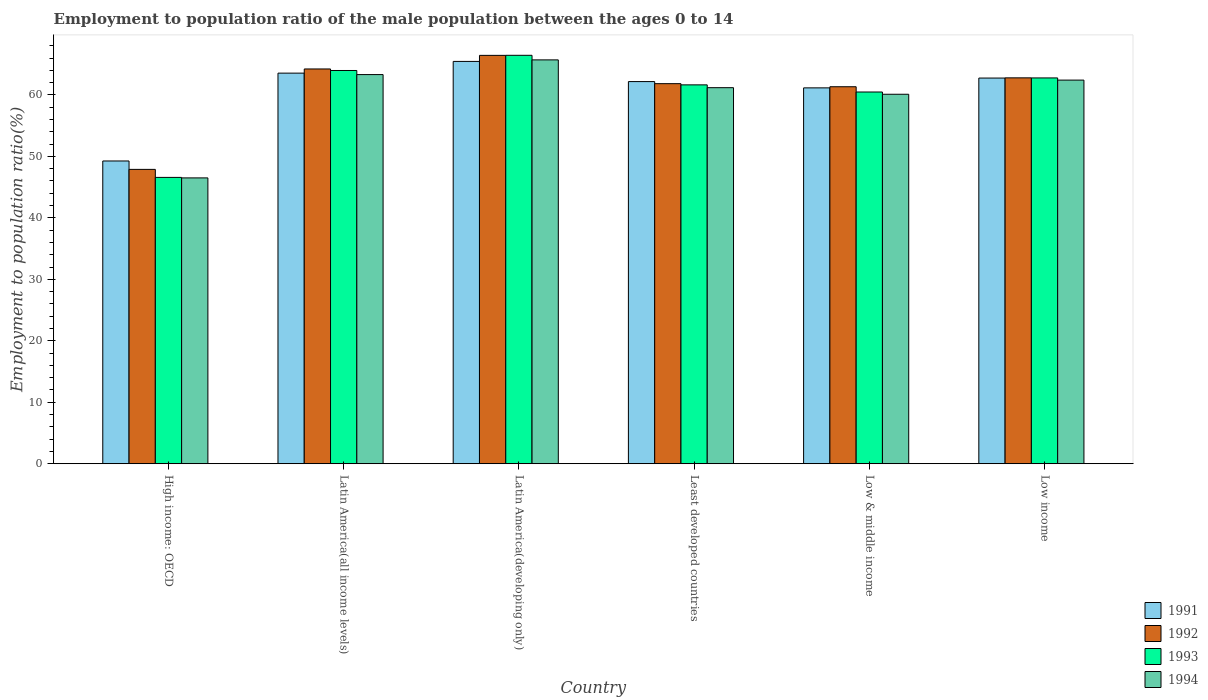Are the number of bars on each tick of the X-axis equal?
Your response must be concise. Yes. How many bars are there on the 2nd tick from the left?
Ensure brevity in your answer.  4. How many bars are there on the 4th tick from the right?
Your answer should be very brief. 4. In how many cases, is the number of bars for a given country not equal to the number of legend labels?
Make the answer very short. 0. What is the employment to population ratio in 1994 in Latin America(all income levels)?
Make the answer very short. 63.31. Across all countries, what is the maximum employment to population ratio in 1994?
Provide a short and direct response. 65.7. Across all countries, what is the minimum employment to population ratio in 1994?
Offer a very short reply. 46.5. In which country was the employment to population ratio in 1991 maximum?
Keep it short and to the point. Latin America(developing only). In which country was the employment to population ratio in 1992 minimum?
Offer a terse response. High income: OECD. What is the total employment to population ratio in 1992 in the graph?
Provide a succinct answer. 364.5. What is the difference between the employment to population ratio in 1992 in Latin America(all income levels) and that in Least developed countries?
Keep it short and to the point. 2.39. What is the difference between the employment to population ratio in 1994 in Latin America(developing only) and the employment to population ratio in 1993 in Low income?
Provide a succinct answer. 2.94. What is the average employment to population ratio in 1994 per country?
Provide a short and direct response. 59.87. What is the difference between the employment to population ratio of/in 1991 and employment to population ratio of/in 1994 in Latin America(all income levels)?
Make the answer very short. 0.24. What is the ratio of the employment to population ratio in 1994 in Latin America(developing only) to that in Low & middle income?
Provide a succinct answer. 1.09. Is the difference between the employment to population ratio in 1991 in Latin America(developing only) and Low income greater than the difference between the employment to population ratio in 1994 in Latin America(developing only) and Low income?
Provide a succinct answer. No. What is the difference between the highest and the second highest employment to population ratio in 1991?
Make the answer very short. 2.71. What is the difference between the highest and the lowest employment to population ratio in 1992?
Offer a very short reply. 18.55. Is it the case that in every country, the sum of the employment to population ratio in 1994 and employment to population ratio in 1993 is greater than the sum of employment to population ratio in 1992 and employment to population ratio in 1991?
Make the answer very short. No. What does the 1st bar from the left in High income: OECD represents?
Keep it short and to the point. 1991. How many bars are there?
Keep it short and to the point. 24. Are all the bars in the graph horizontal?
Give a very brief answer. No. What is the difference between two consecutive major ticks on the Y-axis?
Your answer should be very brief. 10. Are the values on the major ticks of Y-axis written in scientific E-notation?
Offer a terse response. No. Where does the legend appear in the graph?
Your response must be concise. Bottom right. What is the title of the graph?
Your response must be concise. Employment to population ratio of the male population between the ages 0 to 14. What is the label or title of the X-axis?
Your answer should be compact. Country. What is the label or title of the Y-axis?
Your answer should be compact. Employment to population ratio(%). What is the Employment to population ratio(%) in 1991 in High income: OECD?
Keep it short and to the point. 49.25. What is the Employment to population ratio(%) in 1992 in High income: OECD?
Your answer should be compact. 47.89. What is the Employment to population ratio(%) in 1993 in High income: OECD?
Your response must be concise. 46.58. What is the Employment to population ratio(%) in 1994 in High income: OECD?
Give a very brief answer. 46.5. What is the Employment to population ratio(%) of 1991 in Latin America(all income levels)?
Your response must be concise. 63.55. What is the Employment to population ratio(%) of 1992 in Latin America(all income levels)?
Make the answer very short. 64.22. What is the Employment to population ratio(%) in 1993 in Latin America(all income levels)?
Your answer should be very brief. 63.98. What is the Employment to population ratio(%) in 1994 in Latin America(all income levels)?
Make the answer very short. 63.31. What is the Employment to population ratio(%) in 1991 in Latin America(developing only)?
Give a very brief answer. 65.45. What is the Employment to population ratio(%) in 1992 in Latin America(developing only)?
Make the answer very short. 66.44. What is the Employment to population ratio(%) in 1993 in Latin America(developing only)?
Offer a terse response. 66.45. What is the Employment to population ratio(%) of 1994 in Latin America(developing only)?
Offer a very short reply. 65.7. What is the Employment to population ratio(%) of 1991 in Least developed countries?
Give a very brief answer. 62.17. What is the Employment to population ratio(%) in 1992 in Least developed countries?
Offer a terse response. 61.83. What is the Employment to population ratio(%) in 1993 in Least developed countries?
Ensure brevity in your answer.  61.64. What is the Employment to population ratio(%) in 1994 in Least developed countries?
Ensure brevity in your answer.  61.18. What is the Employment to population ratio(%) in 1991 in Low & middle income?
Give a very brief answer. 61.15. What is the Employment to population ratio(%) of 1992 in Low & middle income?
Offer a terse response. 61.33. What is the Employment to population ratio(%) of 1993 in Low & middle income?
Offer a terse response. 60.48. What is the Employment to population ratio(%) in 1994 in Low & middle income?
Offer a terse response. 60.11. What is the Employment to population ratio(%) of 1991 in Low income?
Ensure brevity in your answer.  62.75. What is the Employment to population ratio(%) of 1992 in Low income?
Keep it short and to the point. 62.78. What is the Employment to population ratio(%) in 1993 in Low income?
Provide a short and direct response. 62.77. What is the Employment to population ratio(%) of 1994 in Low income?
Ensure brevity in your answer.  62.41. Across all countries, what is the maximum Employment to population ratio(%) in 1991?
Give a very brief answer. 65.45. Across all countries, what is the maximum Employment to population ratio(%) in 1992?
Make the answer very short. 66.44. Across all countries, what is the maximum Employment to population ratio(%) in 1993?
Give a very brief answer. 66.45. Across all countries, what is the maximum Employment to population ratio(%) of 1994?
Your answer should be very brief. 65.7. Across all countries, what is the minimum Employment to population ratio(%) in 1991?
Make the answer very short. 49.25. Across all countries, what is the minimum Employment to population ratio(%) of 1992?
Offer a terse response. 47.89. Across all countries, what is the minimum Employment to population ratio(%) of 1993?
Make the answer very short. 46.58. Across all countries, what is the minimum Employment to population ratio(%) of 1994?
Give a very brief answer. 46.5. What is the total Employment to population ratio(%) of 1991 in the graph?
Make the answer very short. 364.32. What is the total Employment to population ratio(%) of 1992 in the graph?
Offer a very short reply. 364.5. What is the total Employment to population ratio(%) in 1993 in the graph?
Offer a terse response. 361.89. What is the total Employment to population ratio(%) of 1994 in the graph?
Offer a terse response. 359.22. What is the difference between the Employment to population ratio(%) of 1991 in High income: OECD and that in Latin America(all income levels)?
Offer a terse response. -14.29. What is the difference between the Employment to population ratio(%) of 1992 in High income: OECD and that in Latin America(all income levels)?
Ensure brevity in your answer.  -16.34. What is the difference between the Employment to population ratio(%) of 1993 in High income: OECD and that in Latin America(all income levels)?
Your response must be concise. -17.39. What is the difference between the Employment to population ratio(%) of 1994 in High income: OECD and that in Latin America(all income levels)?
Your answer should be very brief. -16.81. What is the difference between the Employment to population ratio(%) in 1991 in High income: OECD and that in Latin America(developing only)?
Provide a short and direct response. -16.2. What is the difference between the Employment to population ratio(%) in 1992 in High income: OECD and that in Latin America(developing only)?
Give a very brief answer. -18.55. What is the difference between the Employment to population ratio(%) of 1993 in High income: OECD and that in Latin America(developing only)?
Make the answer very short. -19.87. What is the difference between the Employment to population ratio(%) of 1994 in High income: OECD and that in Latin America(developing only)?
Keep it short and to the point. -19.2. What is the difference between the Employment to population ratio(%) of 1991 in High income: OECD and that in Least developed countries?
Make the answer very short. -12.92. What is the difference between the Employment to population ratio(%) in 1992 in High income: OECD and that in Least developed countries?
Your response must be concise. -13.95. What is the difference between the Employment to population ratio(%) of 1993 in High income: OECD and that in Least developed countries?
Keep it short and to the point. -15.05. What is the difference between the Employment to population ratio(%) in 1994 in High income: OECD and that in Least developed countries?
Keep it short and to the point. -14.68. What is the difference between the Employment to population ratio(%) of 1991 in High income: OECD and that in Low & middle income?
Offer a very short reply. -11.89. What is the difference between the Employment to population ratio(%) in 1992 in High income: OECD and that in Low & middle income?
Provide a succinct answer. -13.44. What is the difference between the Employment to population ratio(%) in 1993 in High income: OECD and that in Low & middle income?
Provide a succinct answer. -13.89. What is the difference between the Employment to population ratio(%) of 1994 in High income: OECD and that in Low & middle income?
Ensure brevity in your answer.  -13.6. What is the difference between the Employment to population ratio(%) of 1991 in High income: OECD and that in Low income?
Offer a very short reply. -13.49. What is the difference between the Employment to population ratio(%) in 1992 in High income: OECD and that in Low income?
Offer a terse response. -14.89. What is the difference between the Employment to population ratio(%) in 1993 in High income: OECD and that in Low income?
Keep it short and to the point. -16.18. What is the difference between the Employment to population ratio(%) in 1994 in High income: OECD and that in Low income?
Your answer should be compact. -15.91. What is the difference between the Employment to population ratio(%) in 1991 in Latin America(all income levels) and that in Latin America(developing only)?
Ensure brevity in your answer.  -1.91. What is the difference between the Employment to population ratio(%) of 1992 in Latin America(all income levels) and that in Latin America(developing only)?
Your answer should be compact. -2.21. What is the difference between the Employment to population ratio(%) of 1993 in Latin America(all income levels) and that in Latin America(developing only)?
Provide a short and direct response. -2.47. What is the difference between the Employment to population ratio(%) of 1994 in Latin America(all income levels) and that in Latin America(developing only)?
Provide a succinct answer. -2.39. What is the difference between the Employment to population ratio(%) in 1991 in Latin America(all income levels) and that in Least developed countries?
Provide a short and direct response. 1.37. What is the difference between the Employment to population ratio(%) of 1992 in Latin America(all income levels) and that in Least developed countries?
Give a very brief answer. 2.39. What is the difference between the Employment to population ratio(%) in 1993 in Latin America(all income levels) and that in Least developed countries?
Keep it short and to the point. 2.34. What is the difference between the Employment to population ratio(%) of 1994 in Latin America(all income levels) and that in Least developed countries?
Your response must be concise. 2.13. What is the difference between the Employment to population ratio(%) in 1991 in Latin America(all income levels) and that in Low & middle income?
Give a very brief answer. 2.4. What is the difference between the Employment to population ratio(%) in 1992 in Latin America(all income levels) and that in Low & middle income?
Your response must be concise. 2.89. What is the difference between the Employment to population ratio(%) in 1993 in Latin America(all income levels) and that in Low & middle income?
Your response must be concise. 3.5. What is the difference between the Employment to population ratio(%) of 1994 in Latin America(all income levels) and that in Low & middle income?
Give a very brief answer. 3.2. What is the difference between the Employment to population ratio(%) of 1991 in Latin America(all income levels) and that in Low income?
Give a very brief answer. 0.8. What is the difference between the Employment to population ratio(%) in 1992 in Latin America(all income levels) and that in Low income?
Offer a very short reply. 1.44. What is the difference between the Employment to population ratio(%) in 1993 in Latin America(all income levels) and that in Low income?
Provide a short and direct response. 1.21. What is the difference between the Employment to population ratio(%) of 1994 in Latin America(all income levels) and that in Low income?
Make the answer very short. 0.9. What is the difference between the Employment to population ratio(%) in 1991 in Latin America(developing only) and that in Least developed countries?
Offer a terse response. 3.28. What is the difference between the Employment to population ratio(%) in 1992 in Latin America(developing only) and that in Least developed countries?
Provide a succinct answer. 4.6. What is the difference between the Employment to population ratio(%) of 1993 in Latin America(developing only) and that in Least developed countries?
Ensure brevity in your answer.  4.81. What is the difference between the Employment to population ratio(%) of 1994 in Latin America(developing only) and that in Least developed countries?
Your answer should be very brief. 4.52. What is the difference between the Employment to population ratio(%) in 1991 in Latin America(developing only) and that in Low & middle income?
Keep it short and to the point. 4.31. What is the difference between the Employment to population ratio(%) of 1992 in Latin America(developing only) and that in Low & middle income?
Give a very brief answer. 5.11. What is the difference between the Employment to population ratio(%) of 1993 in Latin America(developing only) and that in Low & middle income?
Your answer should be compact. 5.97. What is the difference between the Employment to population ratio(%) of 1994 in Latin America(developing only) and that in Low & middle income?
Your answer should be very brief. 5.59. What is the difference between the Employment to population ratio(%) of 1991 in Latin America(developing only) and that in Low income?
Your answer should be compact. 2.71. What is the difference between the Employment to population ratio(%) in 1992 in Latin America(developing only) and that in Low income?
Your answer should be very brief. 3.66. What is the difference between the Employment to population ratio(%) of 1993 in Latin America(developing only) and that in Low income?
Keep it short and to the point. 3.68. What is the difference between the Employment to population ratio(%) of 1994 in Latin America(developing only) and that in Low income?
Keep it short and to the point. 3.29. What is the difference between the Employment to population ratio(%) in 1991 in Least developed countries and that in Low & middle income?
Your answer should be compact. 1.02. What is the difference between the Employment to population ratio(%) of 1992 in Least developed countries and that in Low & middle income?
Give a very brief answer. 0.5. What is the difference between the Employment to population ratio(%) of 1993 in Least developed countries and that in Low & middle income?
Provide a succinct answer. 1.16. What is the difference between the Employment to population ratio(%) of 1994 in Least developed countries and that in Low & middle income?
Your response must be concise. 1.07. What is the difference between the Employment to population ratio(%) in 1991 in Least developed countries and that in Low income?
Ensure brevity in your answer.  -0.57. What is the difference between the Employment to population ratio(%) in 1992 in Least developed countries and that in Low income?
Keep it short and to the point. -0.95. What is the difference between the Employment to population ratio(%) of 1993 in Least developed countries and that in Low income?
Provide a succinct answer. -1.13. What is the difference between the Employment to population ratio(%) of 1994 in Least developed countries and that in Low income?
Offer a very short reply. -1.23. What is the difference between the Employment to population ratio(%) in 1991 in Low & middle income and that in Low income?
Provide a short and direct response. -1.6. What is the difference between the Employment to population ratio(%) in 1992 in Low & middle income and that in Low income?
Your answer should be compact. -1.45. What is the difference between the Employment to population ratio(%) of 1993 in Low & middle income and that in Low income?
Your answer should be very brief. -2.29. What is the difference between the Employment to population ratio(%) in 1994 in Low & middle income and that in Low income?
Give a very brief answer. -2.3. What is the difference between the Employment to population ratio(%) of 1991 in High income: OECD and the Employment to population ratio(%) of 1992 in Latin America(all income levels)?
Give a very brief answer. -14.97. What is the difference between the Employment to population ratio(%) of 1991 in High income: OECD and the Employment to population ratio(%) of 1993 in Latin America(all income levels)?
Your answer should be very brief. -14.72. What is the difference between the Employment to population ratio(%) in 1991 in High income: OECD and the Employment to population ratio(%) in 1994 in Latin America(all income levels)?
Offer a terse response. -14.06. What is the difference between the Employment to population ratio(%) of 1992 in High income: OECD and the Employment to population ratio(%) of 1993 in Latin America(all income levels)?
Provide a short and direct response. -16.09. What is the difference between the Employment to population ratio(%) in 1992 in High income: OECD and the Employment to population ratio(%) in 1994 in Latin America(all income levels)?
Keep it short and to the point. -15.42. What is the difference between the Employment to population ratio(%) of 1993 in High income: OECD and the Employment to population ratio(%) of 1994 in Latin America(all income levels)?
Give a very brief answer. -16.73. What is the difference between the Employment to population ratio(%) of 1991 in High income: OECD and the Employment to population ratio(%) of 1992 in Latin America(developing only)?
Give a very brief answer. -17.18. What is the difference between the Employment to population ratio(%) of 1991 in High income: OECD and the Employment to population ratio(%) of 1993 in Latin America(developing only)?
Offer a terse response. -17.19. What is the difference between the Employment to population ratio(%) in 1991 in High income: OECD and the Employment to population ratio(%) in 1994 in Latin America(developing only)?
Your answer should be very brief. -16.45. What is the difference between the Employment to population ratio(%) in 1992 in High income: OECD and the Employment to population ratio(%) in 1993 in Latin America(developing only)?
Your answer should be compact. -18.56. What is the difference between the Employment to population ratio(%) in 1992 in High income: OECD and the Employment to population ratio(%) in 1994 in Latin America(developing only)?
Keep it short and to the point. -17.81. What is the difference between the Employment to population ratio(%) in 1993 in High income: OECD and the Employment to population ratio(%) in 1994 in Latin America(developing only)?
Your answer should be compact. -19.12. What is the difference between the Employment to population ratio(%) in 1991 in High income: OECD and the Employment to population ratio(%) in 1992 in Least developed countries?
Your response must be concise. -12.58. What is the difference between the Employment to population ratio(%) in 1991 in High income: OECD and the Employment to population ratio(%) in 1993 in Least developed countries?
Your answer should be compact. -12.38. What is the difference between the Employment to population ratio(%) of 1991 in High income: OECD and the Employment to population ratio(%) of 1994 in Least developed countries?
Give a very brief answer. -11.93. What is the difference between the Employment to population ratio(%) of 1992 in High income: OECD and the Employment to population ratio(%) of 1993 in Least developed countries?
Offer a very short reply. -13.75. What is the difference between the Employment to population ratio(%) of 1992 in High income: OECD and the Employment to population ratio(%) of 1994 in Least developed countries?
Ensure brevity in your answer.  -13.29. What is the difference between the Employment to population ratio(%) in 1993 in High income: OECD and the Employment to population ratio(%) in 1994 in Least developed countries?
Provide a short and direct response. -14.6. What is the difference between the Employment to population ratio(%) of 1991 in High income: OECD and the Employment to population ratio(%) of 1992 in Low & middle income?
Your answer should be compact. -12.08. What is the difference between the Employment to population ratio(%) in 1991 in High income: OECD and the Employment to population ratio(%) in 1993 in Low & middle income?
Provide a succinct answer. -11.22. What is the difference between the Employment to population ratio(%) in 1991 in High income: OECD and the Employment to population ratio(%) in 1994 in Low & middle income?
Your answer should be very brief. -10.85. What is the difference between the Employment to population ratio(%) in 1992 in High income: OECD and the Employment to population ratio(%) in 1993 in Low & middle income?
Keep it short and to the point. -12.59. What is the difference between the Employment to population ratio(%) of 1992 in High income: OECD and the Employment to population ratio(%) of 1994 in Low & middle income?
Give a very brief answer. -12.22. What is the difference between the Employment to population ratio(%) in 1993 in High income: OECD and the Employment to population ratio(%) in 1994 in Low & middle income?
Offer a very short reply. -13.53. What is the difference between the Employment to population ratio(%) in 1991 in High income: OECD and the Employment to population ratio(%) in 1992 in Low income?
Ensure brevity in your answer.  -13.52. What is the difference between the Employment to population ratio(%) of 1991 in High income: OECD and the Employment to population ratio(%) of 1993 in Low income?
Provide a succinct answer. -13.51. What is the difference between the Employment to population ratio(%) of 1991 in High income: OECD and the Employment to population ratio(%) of 1994 in Low income?
Keep it short and to the point. -13.16. What is the difference between the Employment to population ratio(%) of 1992 in High income: OECD and the Employment to population ratio(%) of 1993 in Low income?
Ensure brevity in your answer.  -14.88. What is the difference between the Employment to population ratio(%) of 1992 in High income: OECD and the Employment to population ratio(%) of 1994 in Low income?
Ensure brevity in your answer.  -14.52. What is the difference between the Employment to population ratio(%) in 1993 in High income: OECD and the Employment to population ratio(%) in 1994 in Low income?
Make the answer very short. -15.83. What is the difference between the Employment to population ratio(%) of 1991 in Latin America(all income levels) and the Employment to population ratio(%) of 1992 in Latin America(developing only)?
Your answer should be very brief. -2.89. What is the difference between the Employment to population ratio(%) of 1991 in Latin America(all income levels) and the Employment to population ratio(%) of 1993 in Latin America(developing only)?
Your response must be concise. -2.9. What is the difference between the Employment to population ratio(%) in 1991 in Latin America(all income levels) and the Employment to population ratio(%) in 1994 in Latin America(developing only)?
Offer a terse response. -2.16. What is the difference between the Employment to population ratio(%) in 1992 in Latin America(all income levels) and the Employment to population ratio(%) in 1993 in Latin America(developing only)?
Offer a very short reply. -2.22. What is the difference between the Employment to population ratio(%) in 1992 in Latin America(all income levels) and the Employment to population ratio(%) in 1994 in Latin America(developing only)?
Your answer should be very brief. -1.48. What is the difference between the Employment to population ratio(%) of 1993 in Latin America(all income levels) and the Employment to population ratio(%) of 1994 in Latin America(developing only)?
Offer a terse response. -1.73. What is the difference between the Employment to population ratio(%) in 1991 in Latin America(all income levels) and the Employment to population ratio(%) in 1992 in Least developed countries?
Your answer should be very brief. 1.71. What is the difference between the Employment to population ratio(%) of 1991 in Latin America(all income levels) and the Employment to population ratio(%) of 1993 in Least developed countries?
Offer a terse response. 1.91. What is the difference between the Employment to population ratio(%) in 1991 in Latin America(all income levels) and the Employment to population ratio(%) in 1994 in Least developed countries?
Provide a succinct answer. 2.37. What is the difference between the Employment to population ratio(%) in 1992 in Latin America(all income levels) and the Employment to population ratio(%) in 1993 in Least developed countries?
Offer a very short reply. 2.59. What is the difference between the Employment to population ratio(%) of 1992 in Latin America(all income levels) and the Employment to population ratio(%) of 1994 in Least developed countries?
Your response must be concise. 3.04. What is the difference between the Employment to population ratio(%) of 1993 in Latin America(all income levels) and the Employment to population ratio(%) of 1994 in Least developed countries?
Offer a terse response. 2.8. What is the difference between the Employment to population ratio(%) of 1991 in Latin America(all income levels) and the Employment to population ratio(%) of 1992 in Low & middle income?
Make the answer very short. 2.21. What is the difference between the Employment to population ratio(%) in 1991 in Latin America(all income levels) and the Employment to population ratio(%) in 1993 in Low & middle income?
Your response must be concise. 3.07. What is the difference between the Employment to population ratio(%) of 1991 in Latin America(all income levels) and the Employment to population ratio(%) of 1994 in Low & middle income?
Offer a very short reply. 3.44. What is the difference between the Employment to population ratio(%) in 1992 in Latin America(all income levels) and the Employment to population ratio(%) in 1993 in Low & middle income?
Your answer should be compact. 3.75. What is the difference between the Employment to population ratio(%) in 1992 in Latin America(all income levels) and the Employment to population ratio(%) in 1994 in Low & middle income?
Provide a succinct answer. 4.12. What is the difference between the Employment to population ratio(%) of 1993 in Latin America(all income levels) and the Employment to population ratio(%) of 1994 in Low & middle income?
Offer a terse response. 3.87. What is the difference between the Employment to population ratio(%) of 1991 in Latin America(all income levels) and the Employment to population ratio(%) of 1992 in Low income?
Offer a very short reply. 0.77. What is the difference between the Employment to population ratio(%) of 1991 in Latin America(all income levels) and the Employment to population ratio(%) of 1993 in Low income?
Offer a terse response. 0.78. What is the difference between the Employment to population ratio(%) of 1991 in Latin America(all income levels) and the Employment to population ratio(%) of 1994 in Low income?
Your answer should be compact. 1.13. What is the difference between the Employment to population ratio(%) of 1992 in Latin America(all income levels) and the Employment to population ratio(%) of 1993 in Low income?
Ensure brevity in your answer.  1.46. What is the difference between the Employment to population ratio(%) of 1992 in Latin America(all income levels) and the Employment to population ratio(%) of 1994 in Low income?
Keep it short and to the point. 1.81. What is the difference between the Employment to population ratio(%) in 1993 in Latin America(all income levels) and the Employment to population ratio(%) in 1994 in Low income?
Your response must be concise. 1.56. What is the difference between the Employment to population ratio(%) of 1991 in Latin America(developing only) and the Employment to population ratio(%) of 1992 in Least developed countries?
Your answer should be compact. 3.62. What is the difference between the Employment to population ratio(%) in 1991 in Latin America(developing only) and the Employment to population ratio(%) in 1993 in Least developed countries?
Make the answer very short. 3.82. What is the difference between the Employment to population ratio(%) in 1991 in Latin America(developing only) and the Employment to population ratio(%) in 1994 in Least developed countries?
Your answer should be very brief. 4.27. What is the difference between the Employment to population ratio(%) of 1992 in Latin America(developing only) and the Employment to population ratio(%) of 1993 in Least developed countries?
Provide a short and direct response. 4.8. What is the difference between the Employment to population ratio(%) of 1992 in Latin America(developing only) and the Employment to population ratio(%) of 1994 in Least developed countries?
Provide a short and direct response. 5.26. What is the difference between the Employment to population ratio(%) of 1993 in Latin America(developing only) and the Employment to population ratio(%) of 1994 in Least developed countries?
Your response must be concise. 5.27. What is the difference between the Employment to population ratio(%) in 1991 in Latin America(developing only) and the Employment to population ratio(%) in 1992 in Low & middle income?
Make the answer very short. 4.12. What is the difference between the Employment to population ratio(%) of 1991 in Latin America(developing only) and the Employment to population ratio(%) of 1993 in Low & middle income?
Your response must be concise. 4.98. What is the difference between the Employment to population ratio(%) in 1991 in Latin America(developing only) and the Employment to population ratio(%) in 1994 in Low & middle income?
Ensure brevity in your answer.  5.35. What is the difference between the Employment to population ratio(%) of 1992 in Latin America(developing only) and the Employment to population ratio(%) of 1993 in Low & middle income?
Provide a succinct answer. 5.96. What is the difference between the Employment to population ratio(%) in 1992 in Latin America(developing only) and the Employment to population ratio(%) in 1994 in Low & middle income?
Offer a very short reply. 6.33. What is the difference between the Employment to population ratio(%) in 1993 in Latin America(developing only) and the Employment to population ratio(%) in 1994 in Low & middle income?
Offer a very short reply. 6.34. What is the difference between the Employment to population ratio(%) in 1991 in Latin America(developing only) and the Employment to population ratio(%) in 1992 in Low income?
Give a very brief answer. 2.67. What is the difference between the Employment to population ratio(%) in 1991 in Latin America(developing only) and the Employment to population ratio(%) in 1993 in Low income?
Provide a short and direct response. 2.69. What is the difference between the Employment to population ratio(%) of 1991 in Latin America(developing only) and the Employment to population ratio(%) of 1994 in Low income?
Your response must be concise. 3.04. What is the difference between the Employment to population ratio(%) in 1992 in Latin America(developing only) and the Employment to population ratio(%) in 1993 in Low income?
Offer a terse response. 3.67. What is the difference between the Employment to population ratio(%) in 1992 in Latin America(developing only) and the Employment to population ratio(%) in 1994 in Low income?
Offer a very short reply. 4.03. What is the difference between the Employment to population ratio(%) of 1993 in Latin America(developing only) and the Employment to population ratio(%) of 1994 in Low income?
Provide a succinct answer. 4.04. What is the difference between the Employment to population ratio(%) of 1991 in Least developed countries and the Employment to population ratio(%) of 1992 in Low & middle income?
Keep it short and to the point. 0.84. What is the difference between the Employment to population ratio(%) of 1991 in Least developed countries and the Employment to population ratio(%) of 1993 in Low & middle income?
Ensure brevity in your answer.  1.7. What is the difference between the Employment to population ratio(%) of 1991 in Least developed countries and the Employment to population ratio(%) of 1994 in Low & middle income?
Your answer should be compact. 2.06. What is the difference between the Employment to population ratio(%) in 1992 in Least developed countries and the Employment to population ratio(%) in 1993 in Low & middle income?
Your answer should be compact. 1.36. What is the difference between the Employment to population ratio(%) of 1992 in Least developed countries and the Employment to population ratio(%) of 1994 in Low & middle income?
Your response must be concise. 1.73. What is the difference between the Employment to population ratio(%) of 1993 in Least developed countries and the Employment to population ratio(%) of 1994 in Low & middle income?
Provide a succinct answer. 1.53. What is the difference between the Employment to population ratio(%) in 1991 in Least developed countries and the Employment to population ratio(%) in 1992 in Low income?
Give a very brief answer. -0.61. What is the difference between the Employment to population ratio(%) of 1991 in Least developed countries and the Employment to population ratio(%) of 1993 in Low income?
Provide a succinct answer. -0.59. What is the difference between the Employment to population ratio(%) in 1991 in Least developed countries and the Employment to population ratio(%) in 1994 in Low income?
Keep it short and to the point. -0.24. What is the difference between the Employment to population ratio(%) of 1992 in Least developed countries and the Employment to population ratio(%) of 1993 in Low income?
Make the answer very short. -0.93. What is the difference between the Employment to population ratio(%) of 1992 in Least developed countries and the Employment to population ratio(%) of 1994 in Low income?
Ensure brevity in your answer.  -0.58. What is the difference between the Employment to population ratio(%) in 1993 in Least developed countries and the Employment to population ratio(%) in 1994 in Low income?
Make the answer very short. -0.77. What is the difference between the Employment to population ratio(%) in 1991 in Low & middle income and the Employment to population ratio(%) in 1992 in Low income?
Make the answer very short. -1.63. What is the difference between the Employment to population ratio(%) in 1991 in Low & middle income and the Employment to population ratio(%) in 1993 in Low income?
Ensure brevity in your answer.  -1.62. What is the difference between the Employment to population ratio(%) of 1991 in Low & middle income and the Employment to population ratio(%) of 1994 in Low income?
Give a very brief answer. -1.26. What is the difference between the Employment to population ratio(%) in 1992 in Low & middle income and the Employment to population ratio(%) in 1993 in Low income?
Ensure brevity in your answer.  -1.43. What is the difference between the Employment to population ratio(%) in 1992 in Low & middle income and the Employment to population ratio(%) in 1994 in Low income?
Your answer should be very brief. -1.08. What is the difference between the Employment to population ratio(%) of 1993 in Low & middle income and the Employment to population ratio(%) of 1994 in Low income?
Provide a short and direct response. -1.94. What is the average Employment to population ratio(%) in 1991 per country?
Provide a short and direct response. 60.72. What is the average Employment to population ratio(%) of 1992 per country?
Ensure brevity in your answer.  60.75. What is the average Employment to population ratio(%) of 1993 per country?
Offer a very short reply. 60.31. What is the average Employment to population ratio(%) in 1994 per country?
Your answer should be compact. 59.87. What is the difference between the Employment to population ratio(%) of 1991 and Employment to population ratio(%) of 1992 in High income: OECD?
Give a very brief answer. 1.37. What is the difference between the Employment to population ratio(%) of 1991 and Employment to population ratio(%) of 1993 in High income: OECD?
Make the answer very short. 2.67. What is the difference between the Employment to population ratio(%) of 1991 and Employment to population ratio(%) of 1994 in High income: OECD?
Ensure brevity in your answer.  2.75. What is the difference between the Employment to population ratio(%) in 1992 and Employment to population ratio(%) in 1993 in High income: OECD?
Give a very brief answer. 1.31. What is the difference between the Employment to population ratio(%) of 1992 and Employment to population ratio(%) of 1994 in High income: OECD?
Offer a very short reply. 1.38. What is the difference between the Employment to population ratio(%) in 1993 and Employment to population ratio(%) in 1994 in High income: OECD?
Give a very brief answer. 0.08. What is the difference between the Employment to population ratio(%) in 1991 and Employment to population ratio(%) in 1992 in Latin America(all income levels)?
Ensure brevity in your answer.  -0.68. What is the difference between the Employment to population ratio(%) in 1991 and Employment to population ratio(%) in 1993 in Latin America(all income levels)?
Offer a terse response. -0.43. What is the difference between the Employment to population ratio(%) in 1991 and Employment to population ratio(%) in 1994 in Latin America(all income levels)?
Make the answer very short. 0.24. What is the difference between the Employment to population ratio(%) of 1992 and Employment to population ratio(%) of 1993 in Latin America(all income levels)?
Offer a very short reply. 0.25. What is the difference between the Employment to population ratio(%) in 1992 and Employment to population ratio(%) in 1994 in Latin America(all income levels)?
Offer a terse response. 0.91. What is the difference between the Employment to population ratio(%) of 1993 and Employment to population ratio(%) of 1994 in Latin America(all income levels)?
Give a very brief answer. 0.67. What is the difference between the Employment to population ratio(%) of 1991 and Employment to population ratio(%) of 1992 in Latin America(developing only)?
Your answer should be very brief. -0.98. What is the difference between the Employment to population ratio(%) in 1991 and Employment to population ratio(%) in 1993 in Latin America(developing only)?
Give a very brief answer. -0.99. What is the difference between the Employment to population ratio(%) in 1991 and Employment to population ratio(%) in 1994 in Latin America(developing only)?
Keep it short and to the point. -0.25. What is the difference between the Employment to population ratio(%) of 1992 and Employment to population ratio(%) of 1993 in Latin America(developing only)?
Keep it short and to the point. -0.01. What is the difference between the Employment to population ratio(%) of 1992 and Employment to population ratio(%) of 1994 in Latin America(developing only)?
Your response must be concise. 0.74. What is the difference between the Employment to population ratio(%) of 1993 and Employment to population ratio(%) of 1994 in Latin America(developing only)?
Give a very brief answer. 0.75. What is the difference between the Employment to population ratio(%) of 1991 and Employment to population ratio(%) of 1992 in Least developed countries?
Make the answer very short. 0.34. What is the difference between the Employment to population ratio(%) in 1991 and Employment to population ratio(%) in 1993 in Least developed countries?
Your response must be concise. 0.54. What is the difference between the Employment to population ratio(%) of 1991 and Employment to population ratio(%) of 1994 in Least developed countries?
Offer a very short reply. 0.99. What is the difference between the Employment to population ratio(%) in 1992 and Employment to population ratio(%) in 1993 in Least developed countries?
Give a very brief answer. 0.2. What is the difference between the Employment to population ratio(%) of 1992 and Employment to population ratio(%) of 1994 in Least developed countries?
Offer a terse response. 0.65. What is the difference between the Employment to population ratio(%) of 1993 and Employment to population ratio(%) of 1994 in Least developed countries?
Ensure brevity in your answer.  0.46. What is the difference between the Employment to population ratio(%) in 1991 and Employment to population ratio(%) in 1992 in Low & middle income?
Provide a succinct answer. -0.18. What is the difference between the Employment to population ratio(%) in 1991 and Employment to population ratio(%) in 1993 in Low & middle income?
Your answer should be very brief. 0.67. What is the difference between the Employment to population ratio(%) of 1991 and Employment to population ratio(%) of 1994 in Low & middle income?
Keep it short and to the point. 1.04. What is the difference between the Employment to population ratio(%) of 1992 and Employment to population ratio(%) of 1993 in Low & middle income?
Your response must be concise. 0.86. What is the difference between the Employment to population ratio(%) of 1992 and Employment to population ratio(%) of 1994 in Low & middle income?
Give a very brief answer. 1.22. What is the difference between the Employment to population ratio(%) in 1993 and Employment to population ratio(%) in 1994 in Low & middle income?
Offer a terse response. 0.37. What is the difference between the Employment to population ratio(%) in 1991 and Employment to population ratio(%) in 1992 in Low income?
Provide a short and direct response. -0.03. What is the difference between the Employment to population ratio(%) of 1991 and Employment to population ratio(%) of 1993 in Low income?
Your response must be concise. -0.02. What is the difference between the Employment to population ratio(%) of 1991 and Employment to population ratio(%) of 1994 in Low income?
Offer a terse response. 0.33. What is the difference between the Employment to population ratio(%) in 1992 and Employment to population ratio(%) in 1993 in Low income?
Ensure brevity in your answer.  0.01. What is the difference between the Employment to population ratio(%) of 1992 and Employment to population ratio(%) of 1994 in Low income?
Offer a very short reply. 0.37. What is the difference between the Employment to population ratio(%) of 1993 and Employment to population ratio(%) of 1994 in Low income?
Offer a very short reply. 0.35. What is the ratio of the Employment to population ratio(%) in 1991 in High income: OECD to that in Latin America(all income levels)?
Ensure brevity in your answer.  0.78. What is the ratio of the Employment to population ratio(%) of 1992 in High income: OECD to that in Latin America(all income levels)?
Provide a succinct answer. 0.75. What is the ratio of the Employment to population ratio(%) of 1993 in High income: OECD to that in Latin America(all income levels)?
Offer a terse response. 0.73. What is the ratio of the Employment to population ratio(%) in 1994 in High income: OECD to that in Latin America(all income levels)?
Ensure brevity in your answer.  0.73. What is the ratio of the Employment to population ratio(%) of 1991 in High income: OECD to that in Latin America(developing only)?
Keep it short and to the point. 0.75. What is the ratio of the Employment to population ratio(%) in 1992 in High income: OECD to that in Latin America(developing only)?
Ensure brevity in your answer.  0.72. What is the ratio of the Employment to population ratio(%) of 1993 in High income: OECD to that in Latin America(developing only)?
Make the answer very short. 0.7. What is the ratio of the Employment to population ratio(%) of 1994 in High income: OECD to that in Latin America(developing only)?
Keep it short and to the point. 0.71. What is the ratio of the Employment to population ratio(%) of 1991 in High income: OECD to that in Least developed countries?
Your answer should be very brief. 0.79. What is the ratio of the Employment to population ratio(%) of 1992 in High income: OECD to that in Least developed countries?
Give a very brief answer. 0.77. What is the ratio of the Employment to population ratio(%) of 1993 in High income: OECD to that in Least developed countries?
Make the answer very short. 0.76. What is the ratio of the Employment to population ratio(%) of 1994 in High income: OECD to that in Least developed countries?
Your answer should be compact. 0.76. What is the ratio of the Employment to population ratio(%) in 1991 in High income: OECD to that in Low & middle income?
Make the answer very short. 0.81. What is the ratio of the Employment to population ratio(%) in 1992 in High income: OECD to that in Low & middle income?
Your answer should be compact. 0.78. What is the ratio of the Employment to population ratio(%) in 1993 in High income: OECD to that in Low & middle income?
Give a very brief answer. 0.77. What is the ratio of the Employment to population ratio(%) of 1994 in High income: OECD to that in Low & middle income?
Provide a short and direct response. 0.77. What is the ratio of the Employment to population ratio(%) of 1991 in High income: OECD to that in Low income?
Offer a terse response. 0.79. What is the ratio of the Employment to population ratio(%) of 1992 in High income: OECD to that in Low income?
Ensure brevity in your answer.  0.76. What is the ratio of the Employment to population ratio(%) in 1993 in High income: OECD to that in Low income?
Offer a very short reply. 0.74. What is the ratio of the Employment to population ratio(%) of 1994 in High income: OECD to that in Low income?
Your answer should be very brief. 0.75. What is the ratio of the Employment to population ratio(%) of 1991 in Latin America(all income levels) to that in Latin America(developing only)?
Your response must be concise. 0.97. What is the ratio of the Employment to population ratio(%) of 1992 in Latin America(all income levels) to that in Latin America(developing only)?
Ensure brevity in your answer.  0.97. What is the ratio of the Employment to population ratio(%) of 1993 in Latin America(all income levels) to that in Latin America(developing only)?
Give a very brief answer. 0.96. What is the ratio of the Employment to population ratio(%) in 1994 in Latin America(all income levels) to that in Latin America(developing only)?
Your answer should be compact. 0.96. What is the ratio of the Employment to population ratio(%) in 1991 in Latin America(all income levels) to that in Least developed countries?
Ensure brevity in your answer.  1.02. What is the ratio of the Employment to population ratio(%) of 1992 in Latin America(all income levels) to that in Least developed countries?
Make the answer very short. 1.04. What is the ratio of the Employment to population ratio(%) of 1993 in Latin America(all income levels) to that in Least developed countries?
Make the answer very short. 1.04. What is the ratio of the Employment to population ratio(%) in 1994 in Latin America(all income levels) to that in Least developed countries?
Offer a terse response. 1.03. What is the ratio of the Employment to population ratio(%) in 1991 in Latin America(all income levels) to that in Low & middle income?
Your answer should be compact. 1.04. What is the ratio of the Employment to population ratio(%) of 1992 in Latin America(all income levels) to that in Low & middle income?
Your response must be concise. 1.05. What is the ratio of the Employment to population ratio(%) in 1993 in Latin America(all income levels) to that in Low & middle income?
Offer a very short reply. 1.06. What is the ratio of the Employment to population ratio(%) in 1994 in Latin America(all income levels) to that in Low & middle income?
Make the answer very short. 1.05. What is the ratio of the Employment to population ratio(%) in 1991 in Latin America(all income levels) to that in Low income?
Ensure brevity in your answer.  1.01. What is the ratio of the Employment to population ratio(%) in 1992 in Latin America(all income levels) to that in Low income?
Your response must be concise. 1.02. What is the ratio of the Employment to population ratio(%) in 1993 in Latin America(all income levels) to that in Low income?
Your response must be concise. 1.02. What is the ratio of the Employment to population ratio(%) in 1994 in Latin America(all income levels) to that in Low income?
Offer a very short reply. 1.01. What is the ratio of the Employment to population ratio(%) in 1991 in Latin America(developing only) to that in Least developed countries?
Offer a very short reply. 1.05. What is the ratio of the Employment to population ratio(%) in 1992 in Latin America(developing only) to that in Least developed countries?
Your response must be concise. 1.07. What is the ratio of the Employment to population ratio(%) of 1993 in Latin America(developing only) to that in Least developed countries?
Your answer should be very brief. 1.08. What is the ratio of the Employment to population ratio(%) in 1994 in Latin America(developing only) to that in Least developed countries?
Give a very brief answer. 1.07. What is the ratio of the Employment to population ratio(%) in 1991 in Latin America(developing only) to that in Low & middle income?
Ensure brevity in your answer.  1.07. What is the ratio of the Employment to population ratio(%) of 1992 in Latin America(developing only) to that in Low & middle income?
Your answer should be very brief. 1.08. What is the ratio of the Employment to population ratio(%) in 1993 in Latin America(developing only) to that in Low & middle income?
Offer a very short reply. 1.1. What is the ratio of the Employment to population ratio(%) of 1994 in Latin America(developing only) to that in Low & middle income?
Keep it short and to the point. 1.09. What is the ratio of the Employment to population ratio(%) of 1991 in Latin America(developing only) to that in Low income?
Keep it short and to the point. 1.04. What is the ratio of the Employment to population ratio(%) of 1992 in Latin America(developing only) to that in Low income?
Make the answer very short. 1.06. What is the ratio of the Employment to population ratio(%) in 1993 in Latin America(developing only) to that in Low income?
Offer a terse response. 1.06. What is the ratio of the Employment to population ratio(%) in 1994 in Latin America(developing only) to that in Low income?
Offer a terse response. 1.05. What is the ratio of the Employment to population ratio(%) of 1991 in Least developed countries to that in Low & middle income?
Make the answer very short. 1.02. What is the ratio of the Employment to population ratio(%) in 1992 in Least developed countries to that in Low & middle income?
Your response must be concise. 1.01. What is the ratio of the Employment to population ratio(%) in 1993 in Least developed countries to that in Low & middle income?
Your response must be concise. 1.02. What is the ratio of the Employment to population ratio(%) in 1994 in Least developed countries to that in Low & middle income?
Offer a terse response. 1.02. What is the ratio of the Employment to population ratio(%) in 1991 in Least developed countries to that in Low income?
Make the answer very short. 0.99. What is the ratio of the Employment to population ratio(%) in 1992 in Least developed countries to that in Low income?
Keep it short and to the point. 0.98. What is the ratio of the Employment to population ratio(%) in 1993 in Least developed countries to that in Low income?
Ensure brevity in your answer.  0.98. What is the ratio of the Employment to population ratio(%) of 1994 in Least developed countries to that in Low income?
Your response must be concise. 0.98. What is the ratio of the Employment to population ratio(%) of 1991 in Low & middle income to that in Low income?
Provide a short and direct response. 0.97. What is the ratio of the Employment to population ratio(%) of 1992 in Low & middle income to that in Low income?
Your answer should be compact. 0.98. What is the ratio of the Employment to population ratio(%) of 1993 in Low & middle income to that in Low income?
Your answer should be very brief. 0.96. What is the ratio of the Employment to population ratio(%) in 1994 in Low & middle income to that in Low income?
Ensure brevity in your answer.  0.96. What is the difference between the highest and the second highest Employment to population ratio(%) of 1991?
Ensure brevity in your answer.  1.91. What is the difference between the highest and the second highest Employment to population ratio(%) in 1992?
Your response must be concise. 2.21. What is the difference between the highest and the second highest Employment to population ratio(%) of 1993?
Your response must be concise. 2.47. What is the difference between the highest and the second highest Employment to population ratio(%) in 1994?
Your answer should be compact. 2.39. What is the difference between the highest and the lowest Employment to population ratio(%) of 1991?
Offer a terse response. 16.2. What is the difference between the highest and the lowest Employment to population ratio(%) in 1992?
Keep it short and to the point. 18.55. What is the difference between the highest and the lowest Employment to population ratio(%) of 1993?
Offer a terse response. 19.87. What is the difference between the highest and the lowest Employment to population ratio(%) of 1994?
Keep it short and to the point. 19.2. 